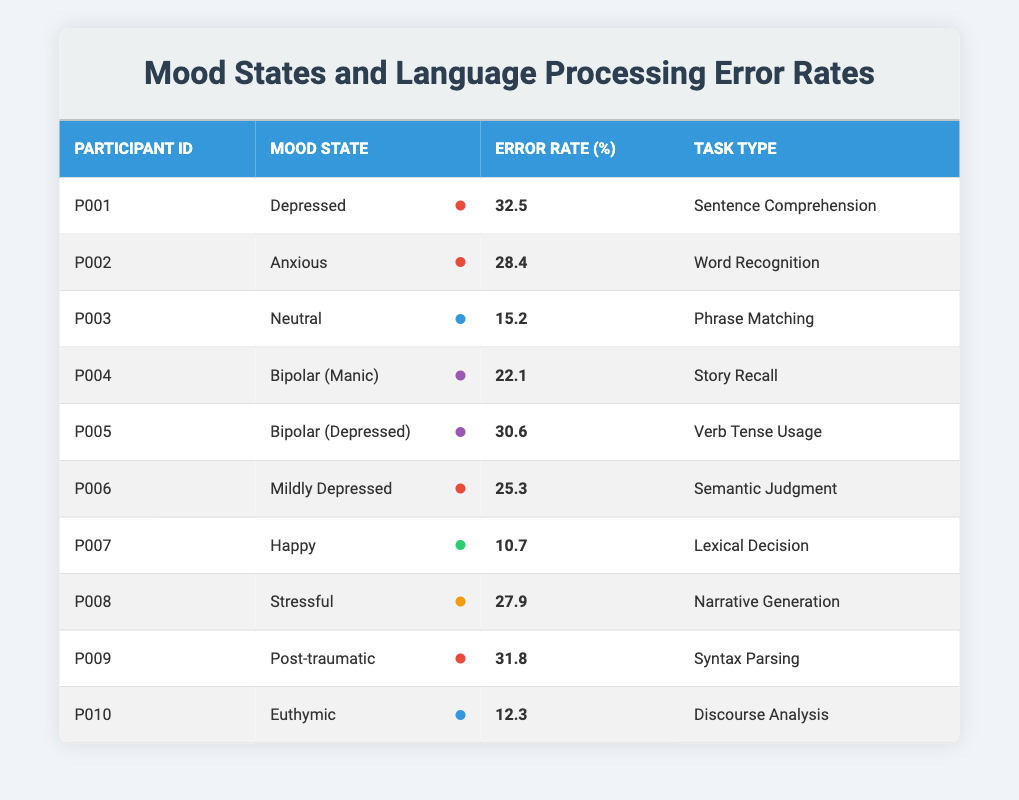What is the highest error rate in the table? The highest error rate is found by scanning the error rates for each participant. The participant with the highest error rate is P001 with 32.5%.
Answer: 32.5% How many participants reported a mood state categorized as "Bipolar"? There are two participants in the table with the mood state categorized as "Bipolar": P004 (Bipolar Manic) and P005 (Bipolar Depressed).
Answer: 2 Which mood state corresponds to the lowest error rate? By looking at the error rates, P007 with a mood state of "Happy" has the lowest error rate of 10.7%.
Answer: Happy What is the average error rate for participants in a Depressed mood state? There are three participants with a Depressed mood state: P001 (32.5%), P006 (25.3%), and P005 (30.6%). Summing them up gives 32.5 + 25.3 + 30.6 = 88.4, and dividing by 3 gives an average of 88.4/3 = 29.47%.
Answer: 29.47% Is the error rate for "Euthymic" higher than for "Neutral"? The error rate for "Euthymic" is 12.3%, while for "Neutral" it is 15.2%. Since 12.3% < 15.2%, the statement is false.
Answer: False If we sum the error rates of participants in a Stressful mood, what is the result? There is one participant in a Stressful mood state, P008, with an error rate of 27.9%. Therefore, the sum of error rates is simply 27.9%.
Answer: 27.9% Which mood states have error rates above 30%? Participants with error rates above 30% are P001 (32.5% - Depressed) and P009 (31.8% - Post-traumatic).
Answer: Depressed, Post-traumatic What is the median error rate of the participants? To find the median, we first list all error rates: 32.5, 28.4, 15.2, 22.1, 30.6, 25.3, 10.7, 27.9, 31.8, 12.3. Sorting these gives: 10.7, 12.3, 15.2, 22.1, 25.3, 27.9, 28.4, 30.6, 31.8, 32.5. The middle values (5th and 6th) are 25.3 and 27.9, so the median is (25.3 + 27.9)/2 = 26.6%.
Answer: 26.6% How does the error rate of "Happy" compare to the average of all participants? The average error rate of all participants is (32.5 + 28.4 + 15.2 + 22.1 + 30.6 + 25.3 + 10.7 + 27.9 + 31.8 + 12.3) / 10 = 23.75%. The error rate for "Happy" is 10.7%, which is lower than the average.
Answer: Lower than average What percentage of participants experienced error rates above 25%? There are 6 participants with error rates above 25% (P001, P002, P005, P006, P008, and P009) out of 10 total participants. Therefore, (6/10) * 100 = 60%.
Answer: 60% 